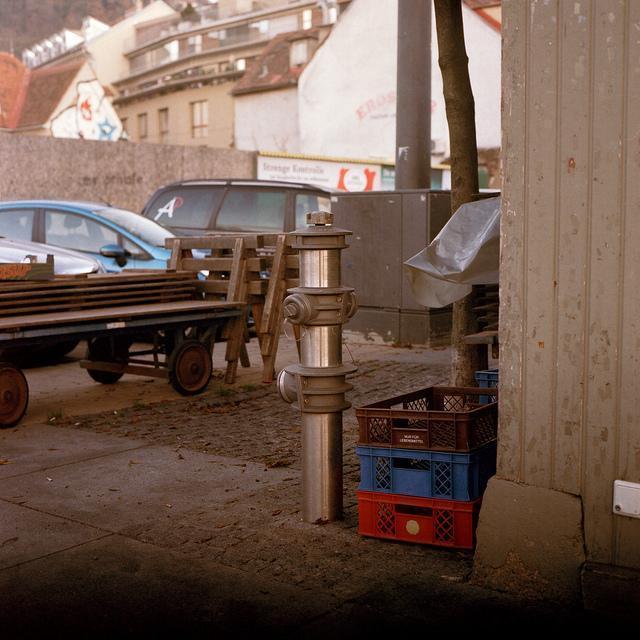What is stacked up near the wall on the right?
Indicate the correct response and explain using: 'Answer: answer
Rationale: rationale.'
Options: Books, crates, bowling pins, cones. Answer: crates.
Rationale: Crates are stacked up 